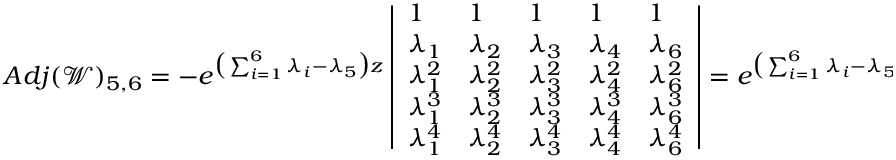Convert formula to latex. <formula><loc_0><loc_0><loc_500><loc_500>A d j ( \ m a t h s c r { W } ) _ { 5 , 6 } = - e ^ { \left ( \sum _ { i = 1 } ^ { 6 } \lambda _ { i } - \lambda _ { 5 } \right ) z } \left | \begin{array} { l l l l l } { 1 } & { 1 } & { 1 } & { 1 } & { 1 } \\ { \lambda _ { 1 } } & { \lambda _ { 2 } } & { \lambda _ { 3 } } & { \lambda _ { 4 } } & { \lambda _ { 6 } } \\ { \lambda _ { 1 } ^ { 2 } } & { \lambda _ { 2 } ^ { 2 } } & { \lambda _ { 3 } ^ { 2 } } & { \lambda _ { 4 } ^ { 2 } } & { \lambda _ { 6 } ^ { 2 } } \\ { \lambda _ { 1 } ^ { 3 } } & { \lambda _ { 2 } ^ { 3 } } & { \lambda _ { 3 } ^ { 3 } } & { \lambda _ { 4 } ^ { 3 } } & { \lambda _ { 6 } ^ { 3 } } \\ { \lambda _ { 1 } ^ { 4 } } & { \lambda _ { 2 } ^ { 4 } } & { \lambda _ { 3 } ^ { 4 } } & { \lambda _ { 4 } ^ { 4 } } & { \lambda _ { 6 } ^ { 4 } } \end{array} \right | = e ^ { \left ( \sum _ { i = 1 } ^ { 6 } \lambda _ { i } - \lambda _ { 5 } \right ) z } \ m a t h s c r { E } _ { \lambda , 5 } ( s )</formula> 